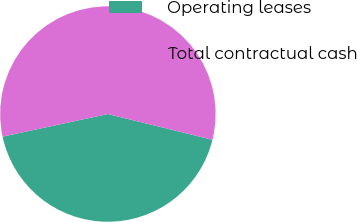Convert chart to OTSL. <chart><loc_0><loc_0><loc_500><loc_500><pie_chart><fcel>Operating leases<fcel>Total contractual cash<nl><fcel>42.79%<fcel>57.21%<nl></chart> 